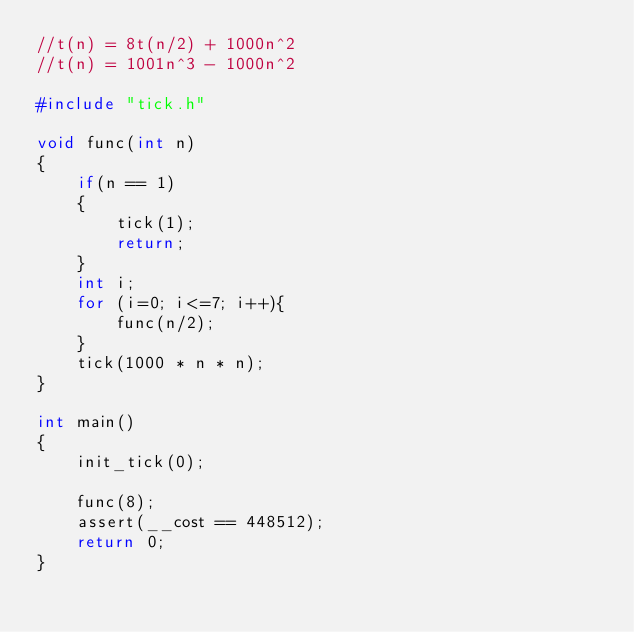Convert code to text. <code><loc_0><loc_0><loc_500><loc_500><_C_>//t(n) = 8t(n/2) + 1000n^2
//t(n) = 1001n^3 - 1000n^2

#include "tick.h"

void func(int n)
{ 
    if(n == 1)
    {
        tick(1);
        return;
    }
    int i;
    for (i=0; i<=7; i++){
        func(n/2);
    }
    tick(1000 * n * n);
}

int main()
{
    init_tick(0);
    
    func(8);
    assert(__cost == 448512);
    return 0;
}
</code> 